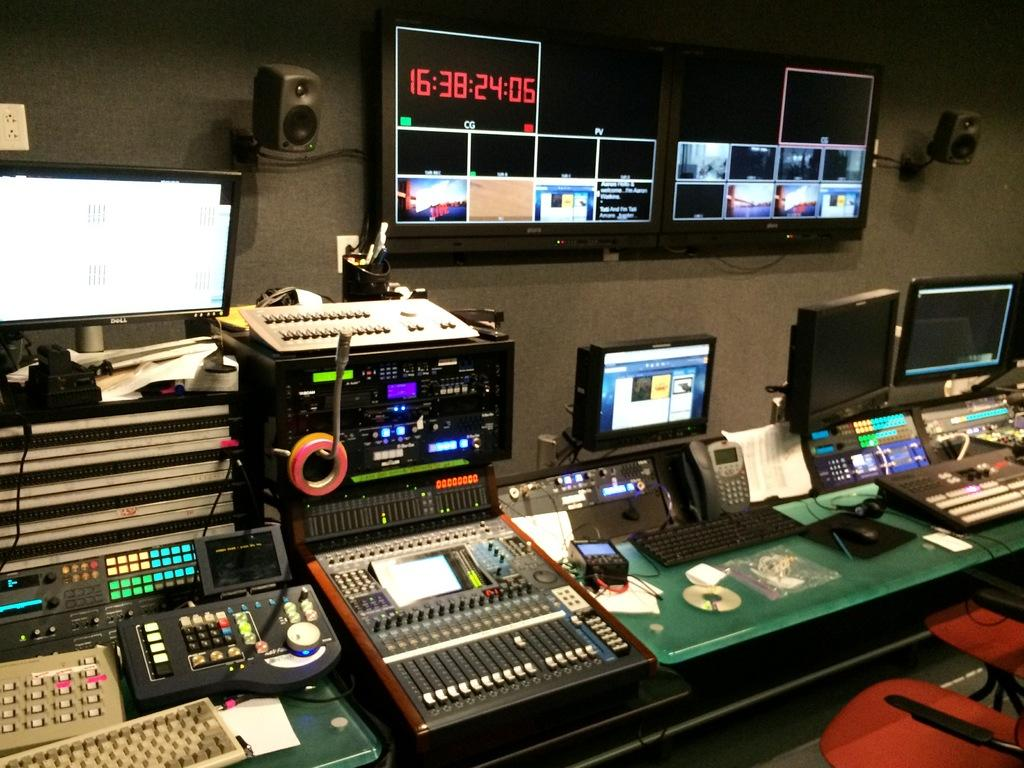<image>
Relay a brief, clear account of the picture shown. A timer that says 16:38:24:05 in red font. 